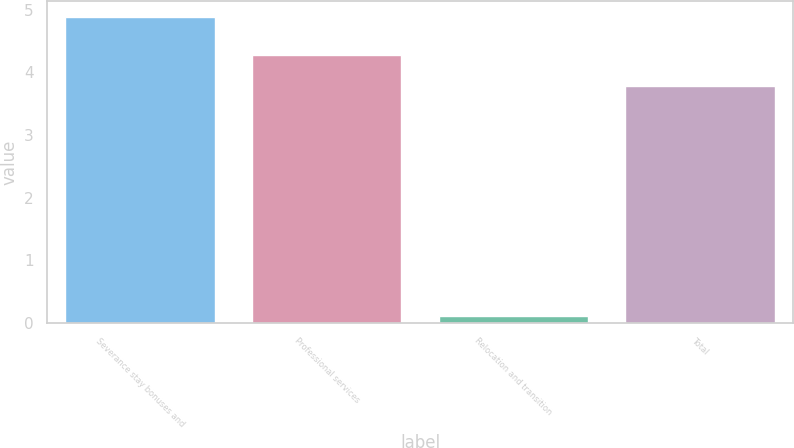<chart> <loc_0><loc_0><loc_500><loc_500><bar_chart><fcel>Severance stay bonuses and<fcel>Professional services<fcel>Relocation and transition<fcel>Total<nl><fcel>4.89<fcel>4.27<fcel>0.12<fcel>3.79<nl></chart> 